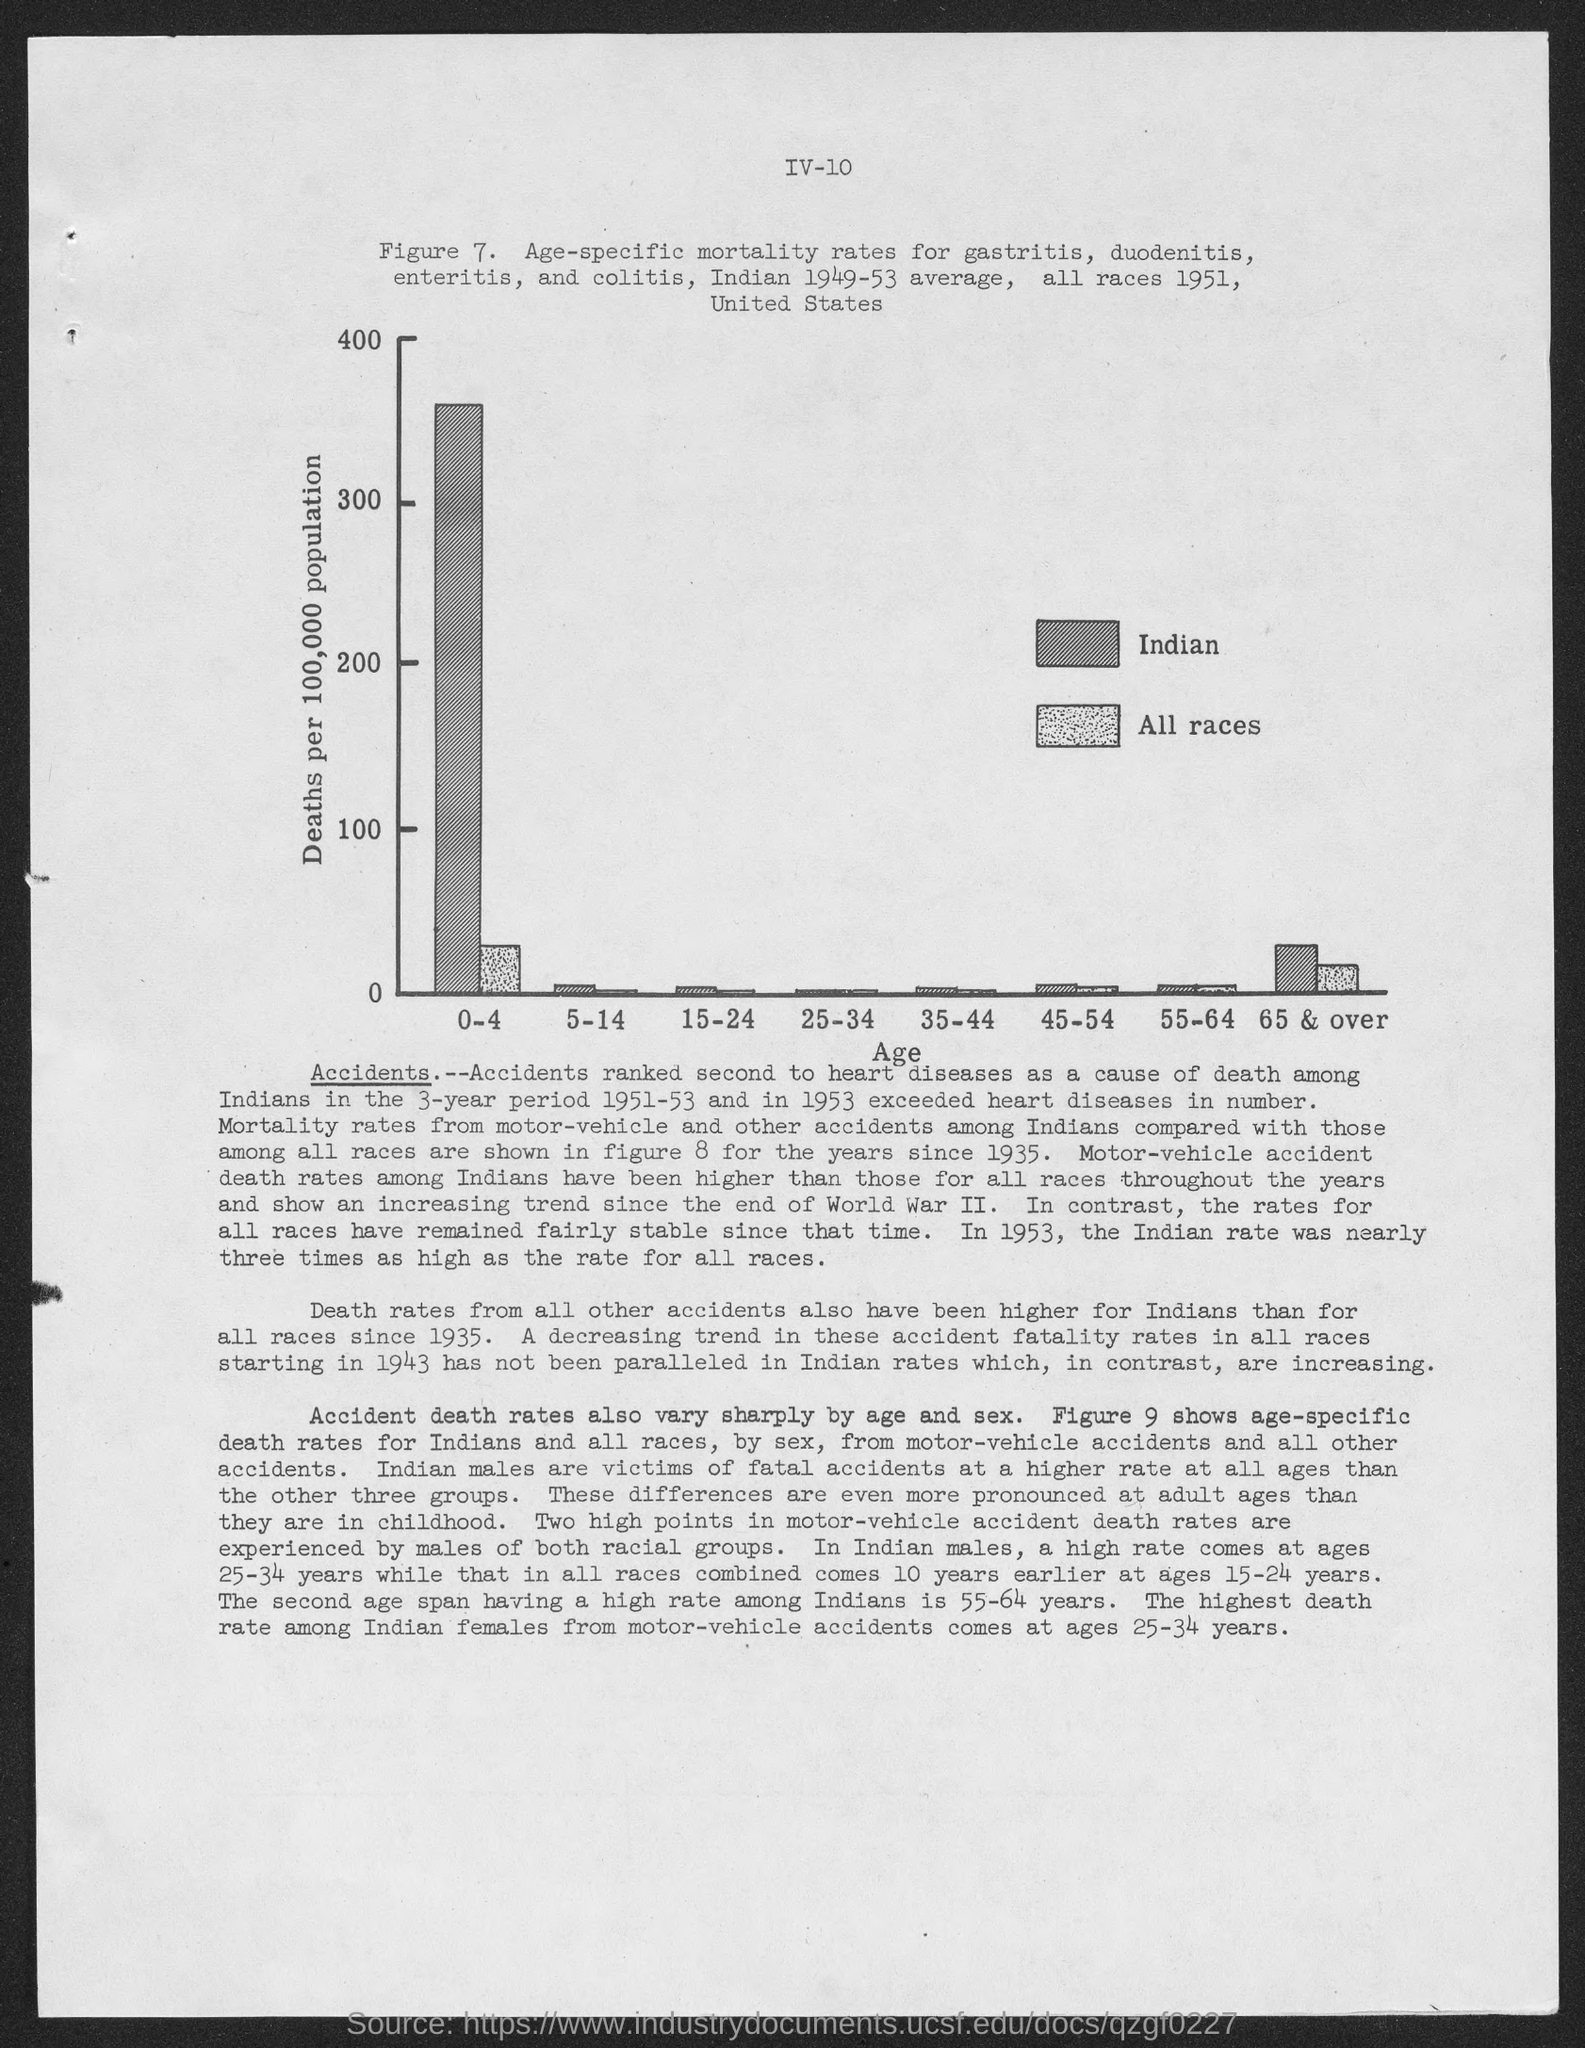In the given bar chart, what is the Y-axis label?
Your answer should be very brief. Deaths per 100,000 population. In the given bar chart, what is the X-axis label?
Make the answer very short. Age. What does the dark shaded bar in the bar chart represent?
Provide a short and direct response. Indian. What does the light shaded bar in the bar chart represent?
Offer a very short reply. All races. 